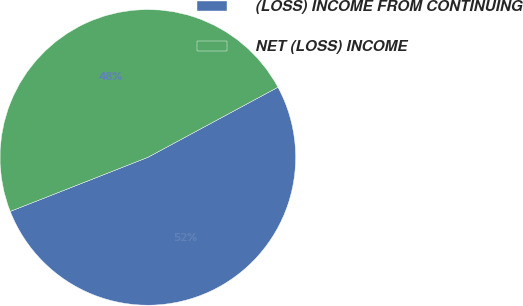Convert chart to OTSL. <chart><loc_0><loc_0><loc_500><loc_500><pie_chart><fcel>(LOSS) INCOME FROM CONTINUING<fcel>NET (LOSS) INCOME<nl><fcel>51.91%<fcel>48.09%<nl></chart> 